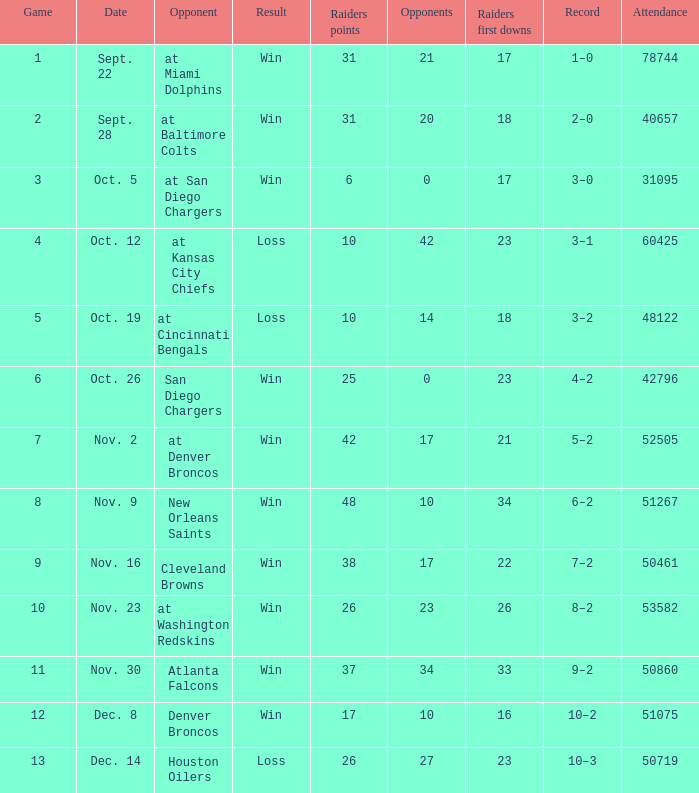What's the all-time best performance in the game played against 42? 3–1. 